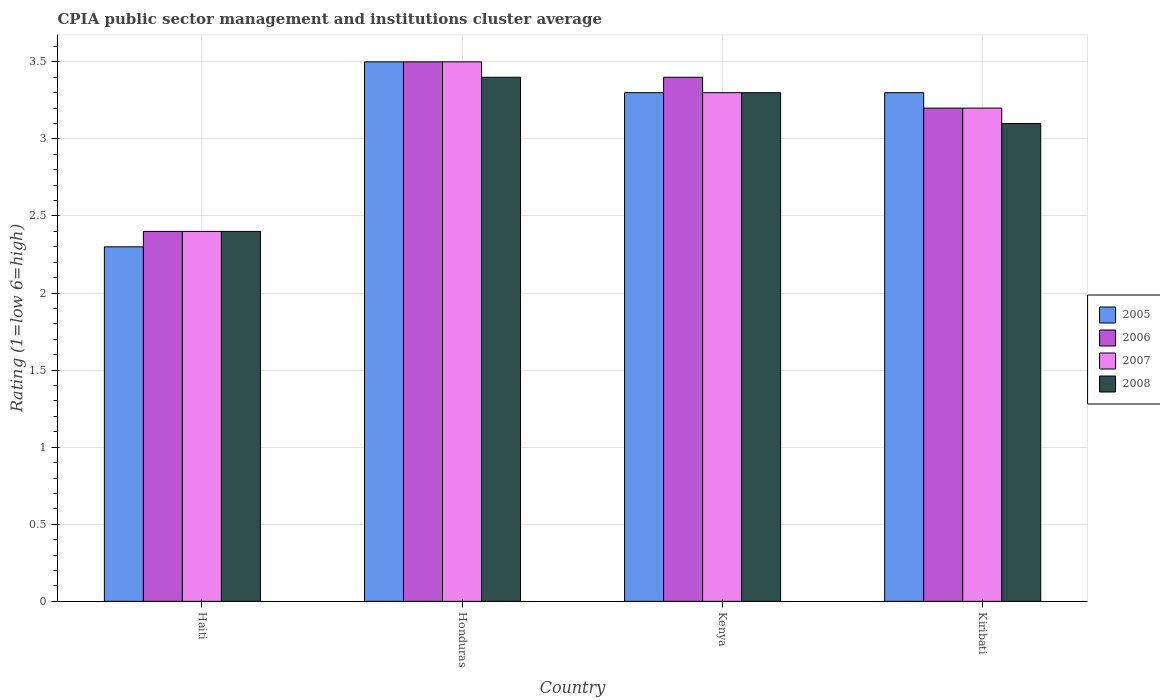How many different coloured bars are there?
Your answer should be compact. 4. How many groups of bars are there?
Offer a very short reply. 4. How many bars are there on the 1st tick from the left?
Provide a succinct answer. 4. How many bars are there on the 2nd tick from the right?
Ensure brevity in your answer.  4. What is the label of the 1st group of bars from the left?
Give a very brief answer. Haiti. In how many cases, is the number of bars for a given country not equal to the number of legend labels?
Offer a terse response. 0. Across all countries, what is the minimum CPIA rating in 2008?
Offer a terse response. 2.4. In which country was the CPIA rating in 2006 maximum?
Make the answer very short. Honduras. In which country was the CPIA rating in 2006 minimum?
Your response must be concise. Haiti. What is the total CPIA rating in 2005 in the graph?
Your answer should be compact. 12.4. What is the difference between the CPIA rating in 2007 in Haiti and that in Kenya?
Offer a terse response. -0.9. What is the difference between the CPIA rating in 2005 in Haiti and the CPIA rating in 2007 in Honduras?
Your answer should be very brief. -1.2. What is the average CPIA rating in 2007 per country?
Provide a short and direct response. 3.1. What is the difference between the CPIA rating of/in 2008 and CPIA rating of/in 2007 in Honduras?
Your answer should be compact. -0.1. What is the ratio of the CPIA rating in 2008 in Honduras to that in Kenya?
Provide a succinct answer. 1.03. What is the difference between the highest and the second highest CPIA rating in 2006?
Provide a short and direct response. -0.1. What is the difference between the highest and the lowest CPIA rating in 2006?
Your response must be concise. 1.1. Is the sum of the CPIA rating in 2008 in Honduras and Kiribati greater than the maximum CPIA rating in 2005 across all countries?
Offer a terse response. Yes. Is it the case that in every country, the sum of the CPIA rating in 2006 and CPIA rating in 2007 is greater than the CPIA rating in 2008?
Provide a succinct answer. Yes. How many bars are there?
Your response must be concise. 16. What is the difference between two consecutive major ticks on the Y-axis?
Your response must be concise. 0.5. Are the values on the major ticks of Y-axis written in scientific E-notation?
Your answer should be compact. No. Does the graph contain any zero values?
Ensure brevity in your answer.  No. How many legend labels are there?
Your answer should be compact. 4. What is the title of the graph?
Keep it short and to the point. CPIA public sector management and institutions cluster average. Does "1982" appear as one of the legend labels in the graph?
Offer a very short reply. No. What is the label or title of the Y-axis?
Ensure brevity in your answer.  Rating (1=low 6=high). What is the Rating (1=low 6=high) of 2005 in Haiti?
Offer a very short reply. 2.3. What is the Rating (1=low 6=high) in 2006 in Haiti?
Offer a terse response. 2.4. What is the Rating (1=low 6=high) in 2007 in Haiti?
Your answer should be compact. 2.4. What is the Rating (1=low 6=high) in 2008 in Haiti?
Provide a succinct answer. 2.4. What is the Rating (1=low 6=high) of 2005 in Honduras?
Your answer should be very brief. 3.5. What is the Rating (1=low 6=high) in 2007 in Honduras?
Offer a terse response. 3.5. What is the Rating (1=low 6=high) of 2008 in Honduras?
Your answer should be compact. 3.4. What is the Rating (1=low 6=high) in 2005 in Kenya?
Provide a succinct answer. 3.3. What is the Rating (1=low 6=high) of 2008 in Kenya?
Offer a terse response. 3.3. What is the Rating (1=low 6=high) in 2006 in Kiribati?
Give a very brief answer. 3.2. Across all countries, what is the maximum Rating (1=low 6=high) of 2007?
Your answer should be very brief. 3.5. Across all countries, what is the minimum Rating (1=low 6=high) of 2005?
Provide a succinct answer. 2.3. What is the total Rating (1=low 6=high) in 2005 in the graph?
Ensure brevity in your answer.  12.4. What is the total Rating (1=low 6=high) of 2007 in the graph?
Keep it short and to the point. 12.4. What is the difference between the Rating (1=low 6=high) of 2006 in Haiti and that in Honduras?
Your response must be concise. -1.1. What is the difference between the Rating (1=low 6=high) of 2007 in Haiti and that in Honduras?
Your answer should be very brief. -1.1. What is the difference between the Rating (1=low 6=high) of 2008 in Haiti and that in Honduras?
Give a very brief answer. -1. What is the difference between the Rating (1=low 6=high) in 2008 in Haiti and that in Kenya?
Provide a succinct answer. -0.9. What is the difference between the Rating (1=low 6=high) in 2005 in Haiti and that in Kiribati?
Provide a short and direct response. -1. What is the difference between the Rating (1=low 6=high) of 2005 in Honduras and that in Kenya?
Offer a very short reply. 0.2. What is the difference between the Rating (1=low 6=high) in 2007 in Honduras and that in Kiribati?
Your answer should be very brief. 0.3. What is the difference between the Rating (1=low 6=high) of 2008 in Honduras and that in Kiribati?
Your answer should be compact. 0.3. What is the difference between the Rating (1=low 6=high) in 2006 in Kenya and that in Kiribati?
Keep it short and to the point. 0.2. What is the difference between the Rating (1=low 6=high) in 2008 in Kenya and that in Kiribati?
Offer a terse response. 0.2. What is the difference between the Rating (1=low 6=high) in 2005 in Haiti and the Rating (1=low 6=high) in 2006 in Honduras?
Provide a succinct answer. -1.2. What is the difference between the Rating (1=low 6=high) in 2005 in Haiti and the Rating (1=low 6=high) in 2008 in Honduras?
Make the answer very short. -1.1. What is the difference between the Rating (1=low 6=high) in 2006 in Haiti and the Rating (1=low 6=high) in 2007 in Honduras?
Give a very brief answer. -1.1. What is the difference between the Rating (1=low 6=high) in 2006 in Haiti and the Rating (1=low 6=high) in 2008 in Honduras?
Your answer should be very brief. -1. What is the difference between the Rating (1=low 6=high) of 2007 in Haiti and the Rating (1=low 6=high) of 2008 in Honduras?
Your answer should be compact. -1. What is the difference between the Rating (1=low 6=high) of 2005 in Haiti and the Rating (1=low 6=high) of 2007 in Kenya?
Provide a succinct answer. -1. What is the difference between the Rating (1=low 6=high) of 2005 in Haiti and the Rating (1=low 6=high) of 2008 in Kenya?
Your answer should be very brief. -1. What is the difference between the Rating (1=low 6=high) in 2006 in Haiti and the Rating (1=low 6=high) in 2007 in Kenya?
Make the answer very short. -0.9. What is the difference between the Rating (1=low 6=high) of 2006 in Haiti and the Rating (1=low 6=high) of 2008 in Kenya?
Ensure brevity in your answer.  -0.9. What is the difference between the Rating (1=low 6=high) of 2007 in Haiti and the Rating (1=low 6=high) of 2008 in Kenya?
Your answer should be compact. -0.9. What is the difference between the Rating (1=low 6=high) of 2005 in Haiti and the Rating (1=low 6=high) of 2006 in Kiribati?
Keep it short and to the point. -0.9. What is the difference between the Rating (1=low 6=high) of 2005 in Haiti and the Rating (1=low 6=high) of 2008 in Kiribati?
Offer a terse response. -0.8. What is the difference between the Rating (1=low 6=high) in 2006 in Haiti and the Rating (1=low 6=high) in 2007 in Kiribati?
Give a very brief answer. -0.8. What is the difference between the Rating (1=low 6=high) of 2006 in Haiti and the Rating (1=low 6=high) of 2008 in Kiribati?
Provide a short and direct response. -0.7. What is the difference between the Rating (1=low 6=high) in 2007 in Haiti and the Rating (1=low 6=high) in 2008 in Kiribati?
Your response must be concise. -0.7. What is the difference between the Rating (1=low 6=high) of 2005 in Honduras and the Rating (1=low 6=high) of 2006 in Kenya?
Make the answer very short. 0.1. What is the difference between the Rating (1=low 6=high) in 2005 in Honduras and the Rating (1=low 6=high) in 2008 in Kenya?
Offer a terse response. 0.2. What is the difference between the Rating (1=low 6=high) in 2006 in Honduras and the Rating (1=low 6=high) in 2007 in Kenya?
Provide a succinct answer. 0.2. What is the difference between the Rating (1=low 6=high) of 2006 in Honduras and the Rating (1=low 6=high) of 2008 in Kenya?
Make the answer very short. 0.2. What is the difference between the Rating (1=low 6=high) of 2005 in Honduras and the Rating (1=low 6=high) of 2007 in Kiribati?
Your response must be concise. 0.3. What is the difference between the Rating (1=low 6=high) of 2005 in Honduras and the Rating (1=low 6=high) of 2008 in Kiribati?
Provide a succinct answer. 0.4. What is the difference between the Rating (1=low 6=high) of 2007 in Honduras and the Rating (1=low 6=high) of 2008 in Kiribati?
Your answer should be very brief. 0.4. What is the difference between the Rating (1=low 6=high) in 2005 in Kenya and the Rating (1=low 6=high) in 2008 in Kiribati?
Ensure brevity in your answer.  0.2. What is the difference between the Rating (1=low 6=high) of 2006 in Kenya and the Rating (1=low 6=high) of 2007 in Kiribati?
Provide a short and direct response. 0.2. What is the difference between the Rating (1=low 6=high) in 2006 in Kenya and the Rating (1=low 6=high) in 2008 in Kiribati?
Make the answer very short. 0.3. What is the average Rating (1=low 6=high) of 2006 per country?
Keep it short and to the point. 3.12. What is the average Rating (1=low 6=high) in 2007 per country?
Make the answer very short. 3.1. What is the average Rating (1=low 6=high) of 2008 per country?
Offer a terse response. 3.05. What is the difference between the Rating (1=low 6=high) of 2006 and Rating (1=low 6=high) of 2007 in Haiti?
Give a very brief answer. 0. What is the difference between the Rating (1=low 6=high) in 2005 and Rating (1=low 6=high) in 2006 in Honduras?
Your answer should be compact. 0. What is the difference between the Rating (1=low 6=high) in 2005 and Rating (1=low 6=high) in 2007 in Honduras?
Ensure brevity in your answer.  0. What is the difference between the Rating (1=low 6=high) of 2005 and Rating (1=low 6=high) of 2008 in Honduras?
Ensure brevity in your answer.  0.1. What is the difference between the Rating (1=low 6=high) of 2007 and Rating (1=low 6=high) of 2008 in Honduras?
Keep it short and to the point. 0.1. What is the difference between the Rating (1=low 6=high) of 2005 and Rating (1=low 6=high) of 2007 in Kenya?
Keep it short and to the point. 0. What is the difference between the Rating (1=low 6=high) in 2007 and Rating (1=low 6=high) in 2008 in Kenya?
Provide a short and direct response. 0. What is the difference between the Rating (1=low 6=high) of 2005 and Rating (1=low 6=high) of 2007 in Kiribati?
Give a very brief answer. 0.1. What is the difference between the Rating (1=low 6=high) of 2006 and Rating (1=low 6=high) of 2008 in Kiribati?
Your response must be concise. 0.1. What is the ratio of the Rating (1=low 6=high) in 2005 in Haiti to that in Honduras?
Keep it short and to the point. 0.66. What is the ratio of the Rating (1=low 6=high) in 2006 in Haiti to that in Honduras?
Give a very brief answer. 0.69. What is the ratio of the Rating (1=low 6=high) of 2007 in Haiti to that in Honduras?
Your answer should be very brief. 0.69. What is the ratio of the Rating (1=low 6=high) in 2008 in Haiti to that in Honduras?
Provide a succinct answer. 0.71. What is the ratio of the Rating (1=low 6=high) of 2005 in Haiti to that in Kenya?
Provide a succinct answer. 0.7. What is the ratio of the Rating (1=low 6=high) of 2006 in Haiti to that in Kenya?
Your answer should be very brief. 0.71. What is the ratio of the Rating (1=low 6=high) of 2007 in Haiti to that in Kenya?
Provide a succinct answer. 0.73. What is the ratio of the Rating (1=low 6=high) in 2008 in Haiti to that in Kenya?
Provide a succinct answer. 0.73. What is the ratio of the Rating (1=low 6=high) in 2005 in Haiti to that in Kiribati?
Ensure brevity in your answer.  0.7. What is the ratio of the Rating (1=low 6=high) in 2007 in Haiti to that in Kiribati?
Give a very brief answer. 0.75. What is the ratio of the Rating (1=low 6=high) in 2008 in Haiti to that in Kiribati?
Make the answer very short. 0.77. What is the ratio of the Rating (1=low 6=high) in 2005 in Honduras to that in Kenya?
Provide a short and direct response. 1.06. What is the ratio of the Rating (1=low 6=high) in 2006 in Honduras to that in Kenya?
Give a very brief answer. 1.03. What is the ratio of the Rating (1=low 6=high) in 2007 in Honduras to that in Kenya?
Offer a terse response. 1.06. What is the ratio of the Rating (1=low 6=high) of 2008 in Honduras to that in Kenya?
Keep it short and to the point. 1.03. What is the ratio of the Rating (1=low 6=high) in 2005 in Honduras to that in Kiribati?
Give a very brief answer. 1.06. What is the ratio of the Rating (1=low 6=high) of 2006 in Honduras to that in Kiribati?
Give a very brief answer. 1.09. What is the ratio of the Rating (1=low 6=high) of 2007 in Honduras to that in Kiribati?
Your answer should be compact. 1.09. What is the ratio of the Rating (1=low 6=high) in 2008 in Honduras to that in Kiribati?
Make the answer very short. 1.1. What is the ratio of the Rating (1=low 6=high) of 2007 in Kenya to that in Kiribati?
Your response must be concise. 1.03. What is the ratio of the Rating (1=low 6=high) in 2008 in Kenya to that in Kiribati?
Offer a very short reply. 1.06. What is the difference between the highest and the second highest Rating (1=low 6=high) in 2005?
Your answer should be compact. 0.2. What is the difference between the highest and the lowest Rating (1=low 6=high) in 2008?
Your answer should be compact. 1. 